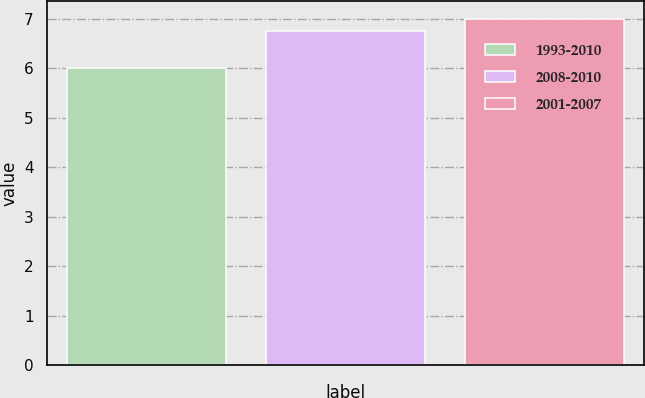<chart> <loc_0><loc_0><loc_500><loc_500><bar_chart><fcel>1993-2010<fcel>2008-2010<fcel>2001-2007<nl><fcel>6<fcel>6.75<fcel>7<nl></chart> 